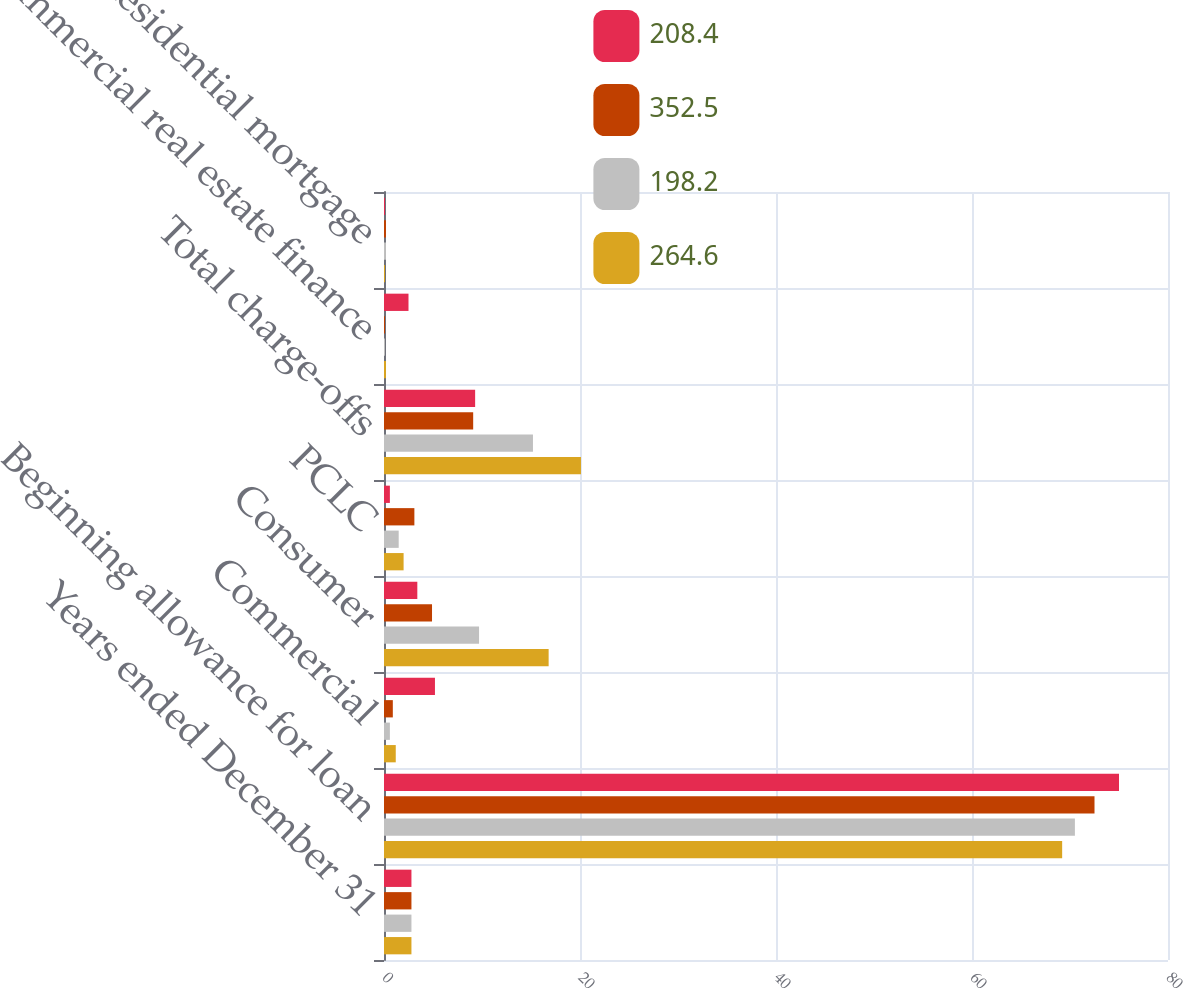<chart> <loc_0><loc_0><loc_500><loc_500><stacked_bar_chart><ecel><fcel>Years ended December 31<fcel>Beginning allowance for loan<fcel>Commercial<fcel>Consumer<fcel>PCLC<fcel>Total charge-offs<fcel>Commercial real estate finance<fcel>Residential mortgage<nl><fcel>208.4<fcel>2.8<fcel>75<fcel>5.2<fcel>3.4<fcel>0.6<fcel>9.3<fcel>2.5<fcel>0.1<nl><fcel>352.5<fcel>2.8<fcel>72.5<fcel>0.9<fcel>4.9<fcel>3.1<fcel>9.1<fcel>0.1<fcel>0.2<nl><fcel>198.2<fcel>2.8<fcel>70.5<fcel>0.6<fcel>9.7<fcel>1.5<fcel>15.2<fcel>0.1<fcel>0.2<nl><fcel>264.6<fcel>2.8<fcel>69.2<fcel>1.2<fcel>16.8<fcel>2<fcel>20.1<fcel>0.2<fcel>0.1<nl></chart> 